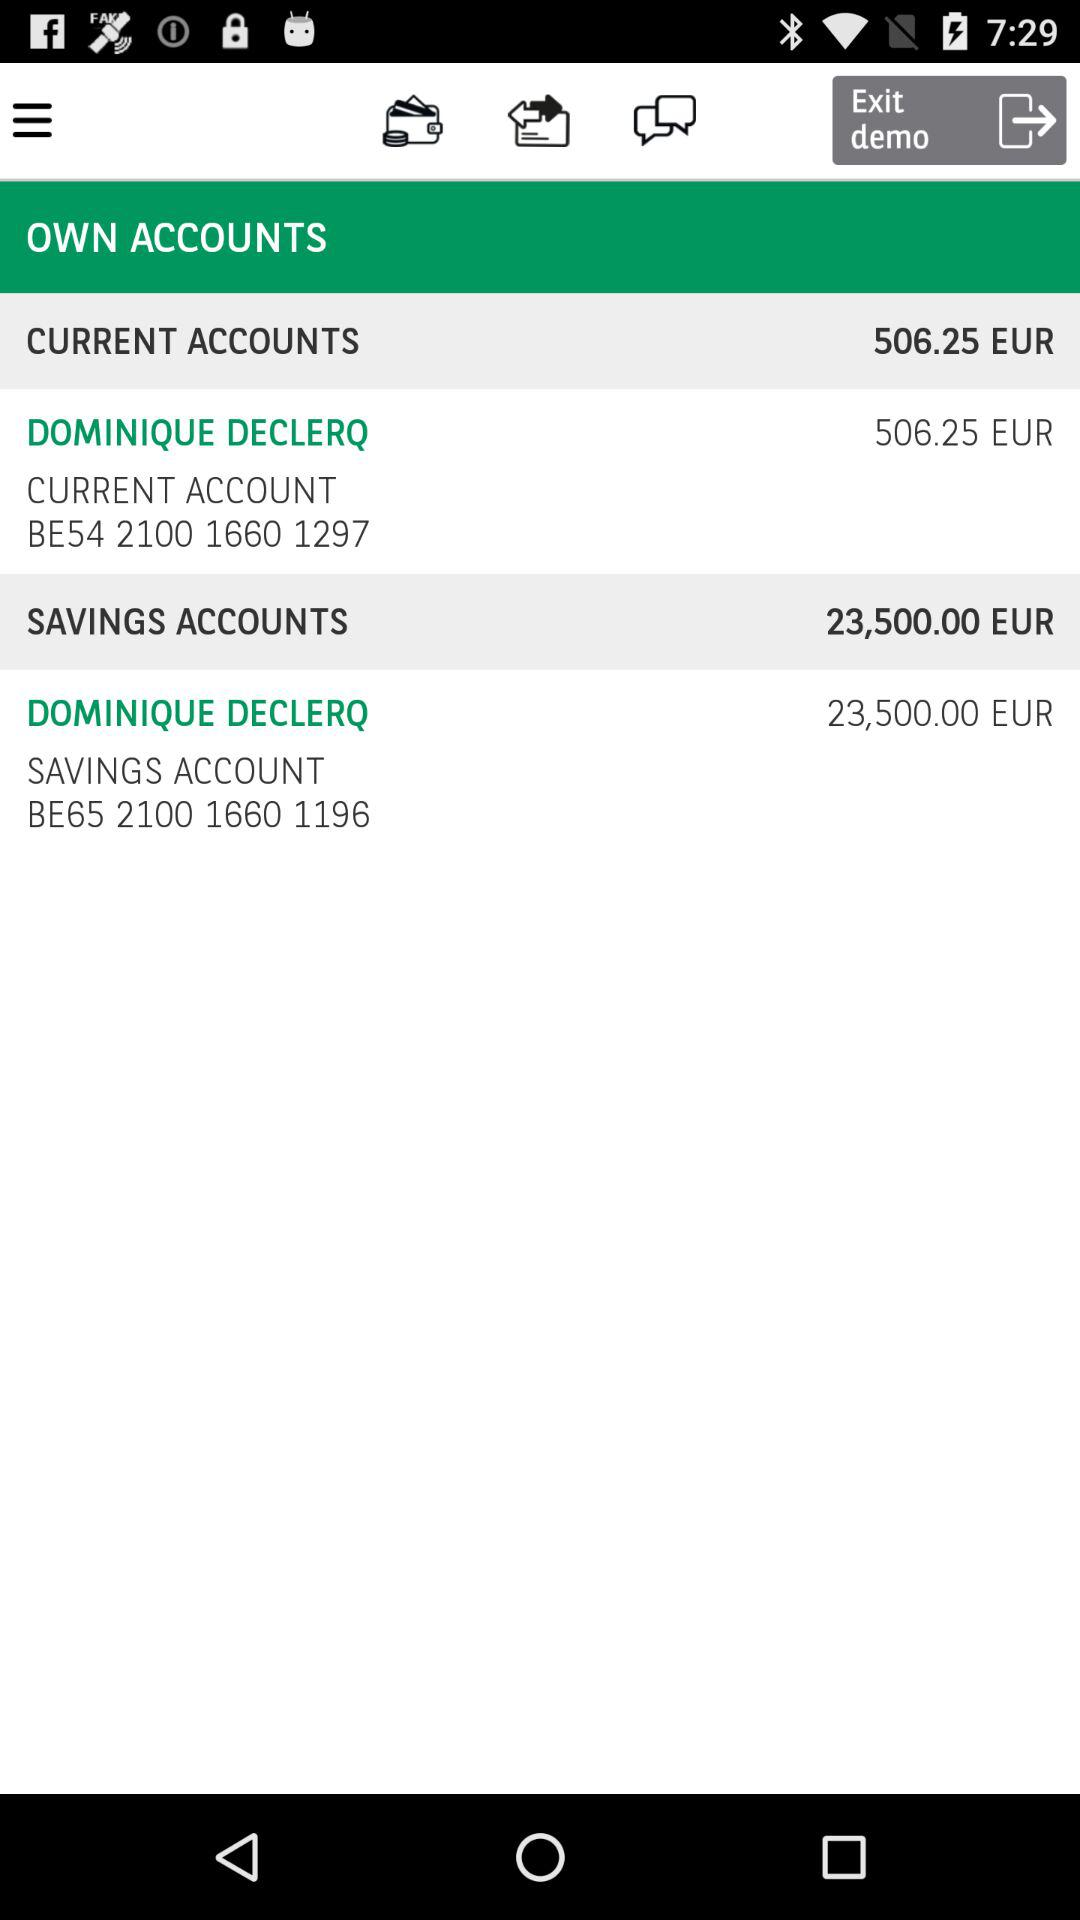What is the given current account number? The given current account number is BE54 2100 1660 1297. 